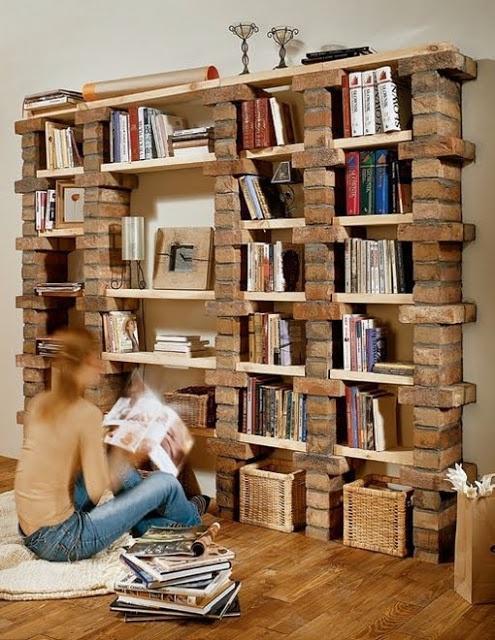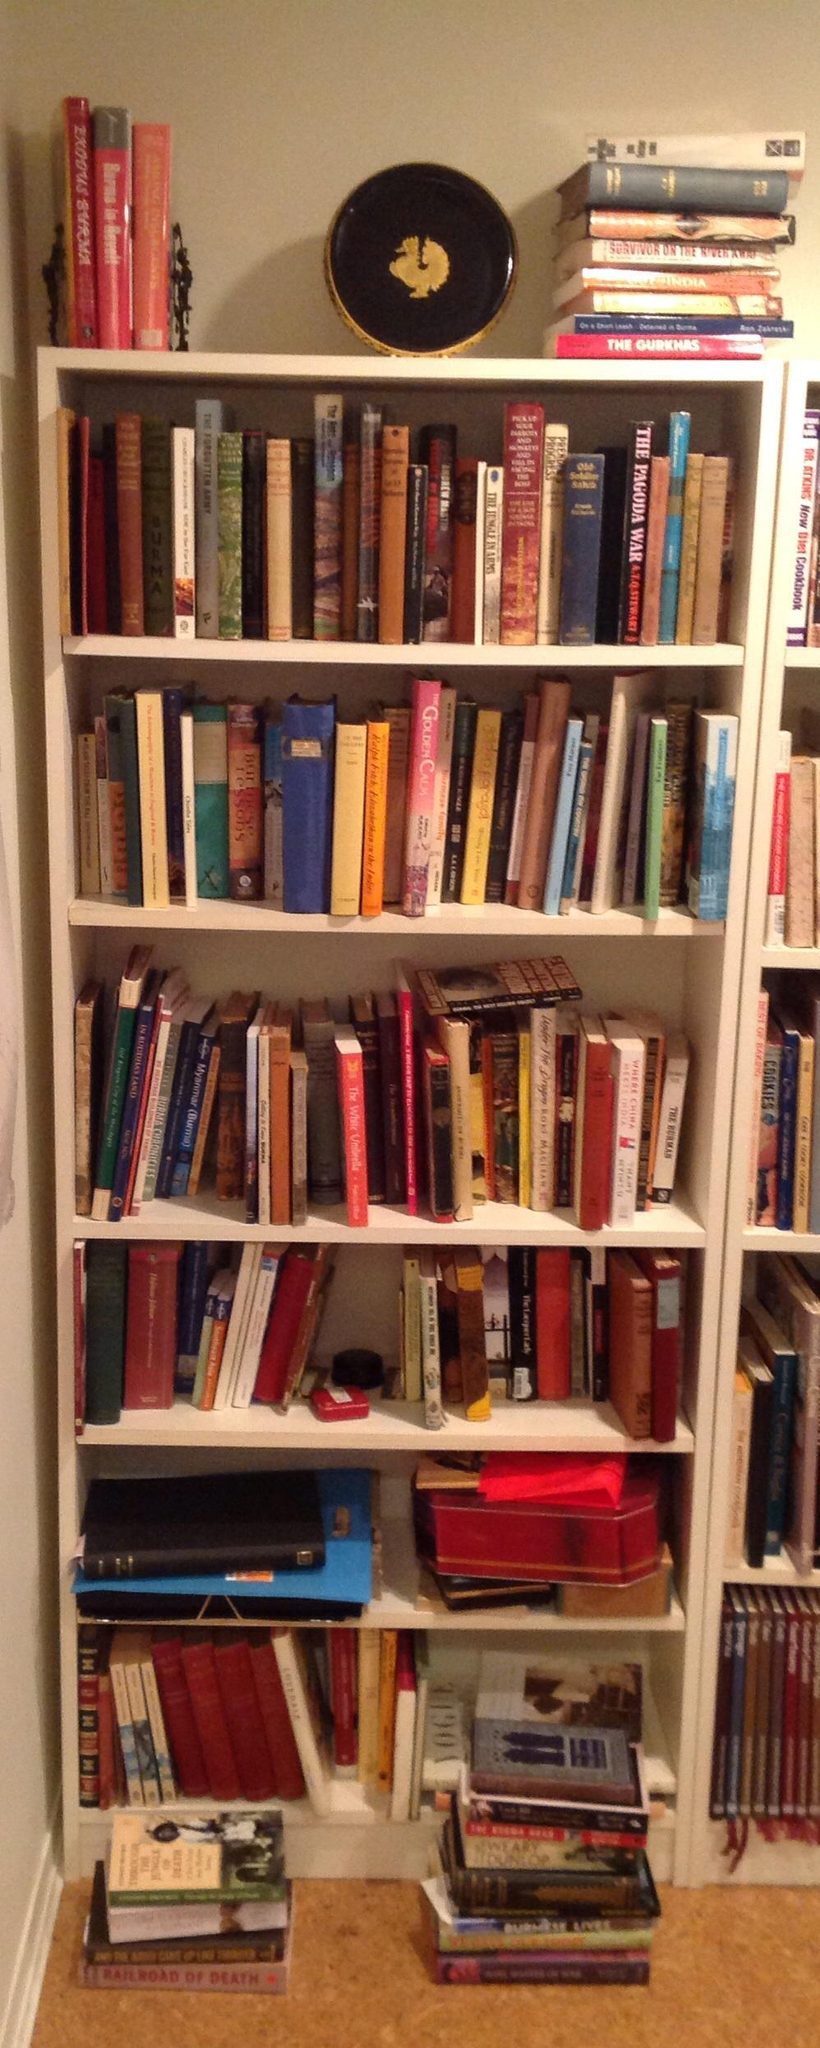The first image is the image on the left, the second image is the image on the right. Assess this claim about the two images: "There are at least three bookshelves made in to one that take up the wall of a room.". Correct or not? Answer yes or no. Yes. The first image is the image on the left, the second image is the image on the right. For the images shown, is this caption "Each bookshelf is freestanding." true? Answer yes or no. No. 